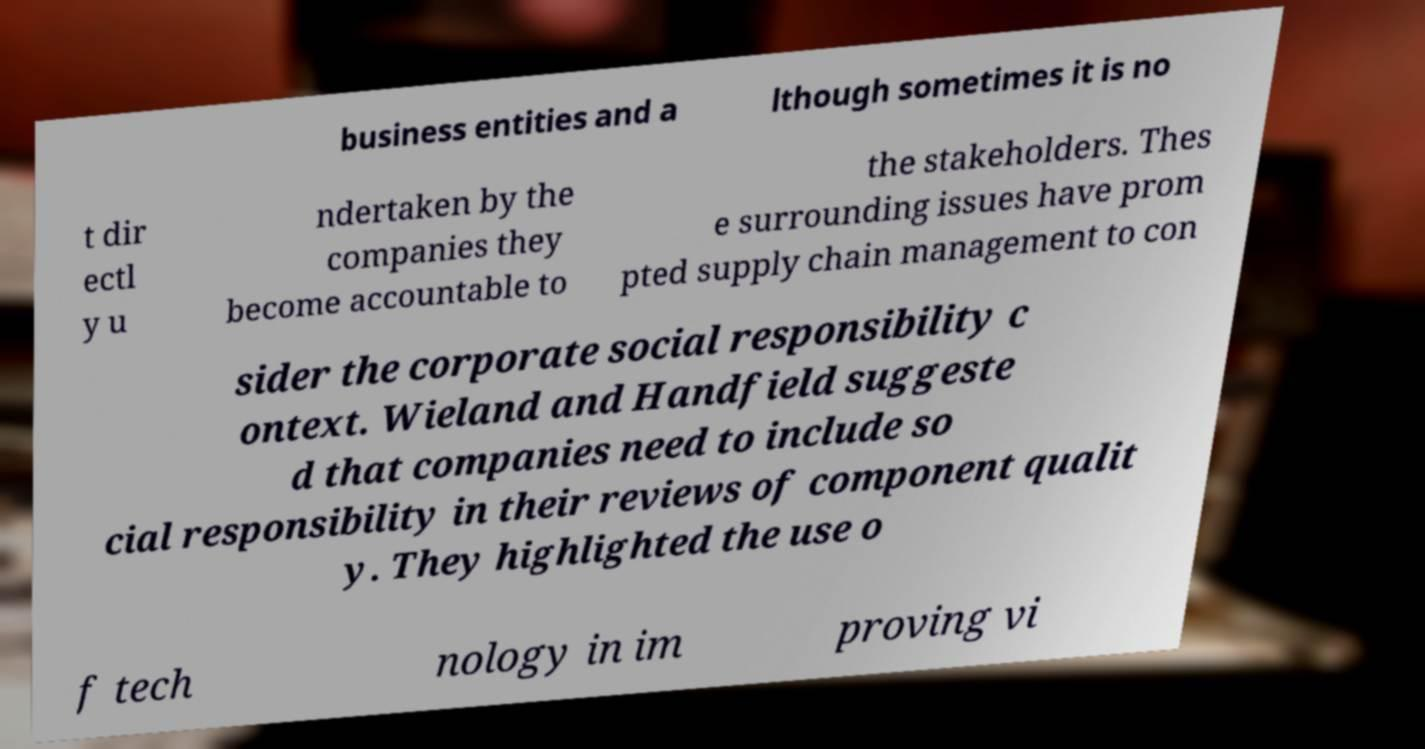Please read and relay the text visible in this image. What does it say? business entities and a lthough sometimes it is no t dir ectl y u ndertaken by the companies they become accountable to the stakeholders. Thes e surrounding issues have prom pted supply chain management to con sider the corporate social responsibility c ontext. Wieland and Handfield suggeste d that companies need to include so cial responsibility in their reviews of component qualit y. They highlighted the use o f tech nology in im proving vi 